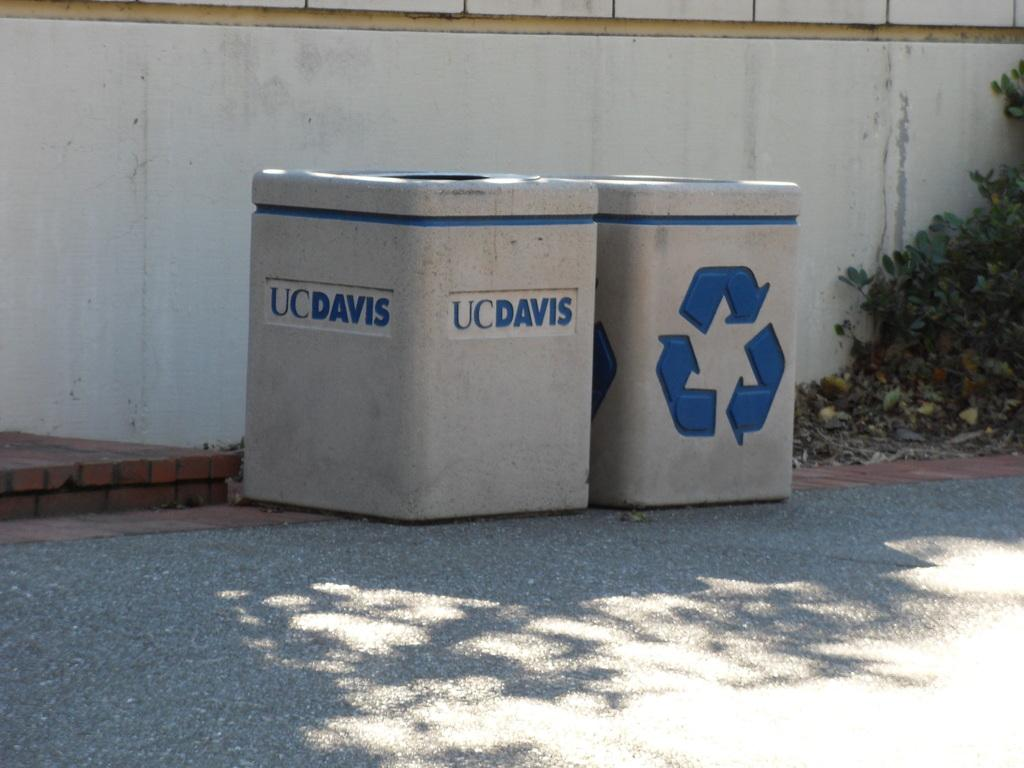<image>
Share a concise interpretation of the image provided. A trash bin and a recycle bin, one of which says UC Davis. 